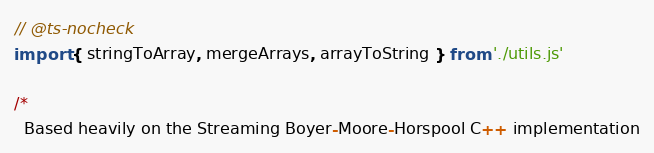<code> <loc_0><loc_0><loc_500><loc_500><_JavaScript_>// @ts-nocheck
import { stringToArray, mergeArrays, arrayToString } from './utils.js'

/*
  Based heavily on the Streaming Boyer-Moore-Horspool C++ implementation</code> 